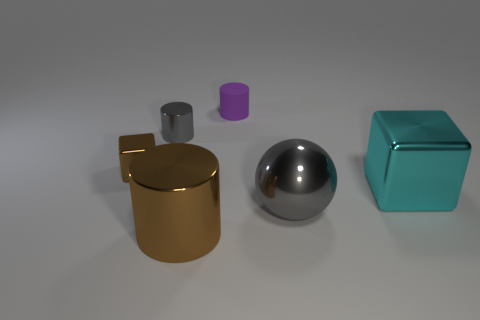Is the number of tiny metal blocks in front of the large cube less than the number of small brown rubber cubes?
Provide a succinct answer. No. What is the material of the brown thing to the left of the big thing that is in front of the big gray sphere that is behind the large shiny cylinder?
Offer a very short reply. Metal. Are there more small brown objects that are behind the purple matte cylinder than gray metallic cylinders that are in front of the small gray metallic thing?
Your answer should be compact. No. What number of rubber objects are large brown cubes or tiny objects?
Your answer should be very brief. 1. There is a thing that is the same color as the tiny block; what shape is it?
Offer a very short reply. Cylinder. There is a brown thing that is to the right of the gray cylinder; what material is it?
Give a very brief answer. Metal. How many objects are either small purple cylinders or things behind the sphere?
Offer a very short reply. 4. There is a brown object that is the same size as the purple cylinder; what shape is it?
Your answer should be compact. Cube. What number of large metal spheres are the same color as the large metallic cylinder?
Provide a succinct answer. 0. Are the cube that is to the right of the large gray shiny sphere and the brown cube made of the same material?
Your answer should be compact. Yes. 